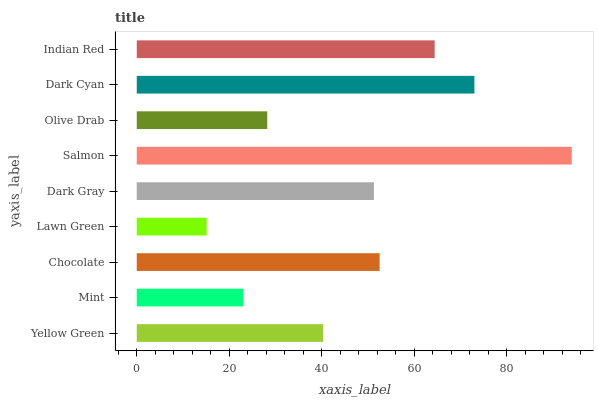Is Lawn Green the minimum?
Answer yes or no. Yes. Is Salmon the maximum?
Answer yes or no. Yes. Is Mint the minimum?
Answer yes or no. No. Is Mint the maximum?
Answer yes or no. No. Is Yellow Green greater than Mint?
Answer yes or no. Yes. Is Mint less than Yellow Green?
Answer yes or no. Yes. Is Mint greater than Yellow Green?
Answer yes or no. No. Is Yellow Green less than Mint?
Answer yes or no. No. Is Dark Gray the high median?
Answer yes or no. Yes. Is Dark Gray the low median?
Answer yes or no. Yes. Is Yellow Green the high median?
Answer yes or no. No. Is Mint the low median?
Answer yes or no. No. 